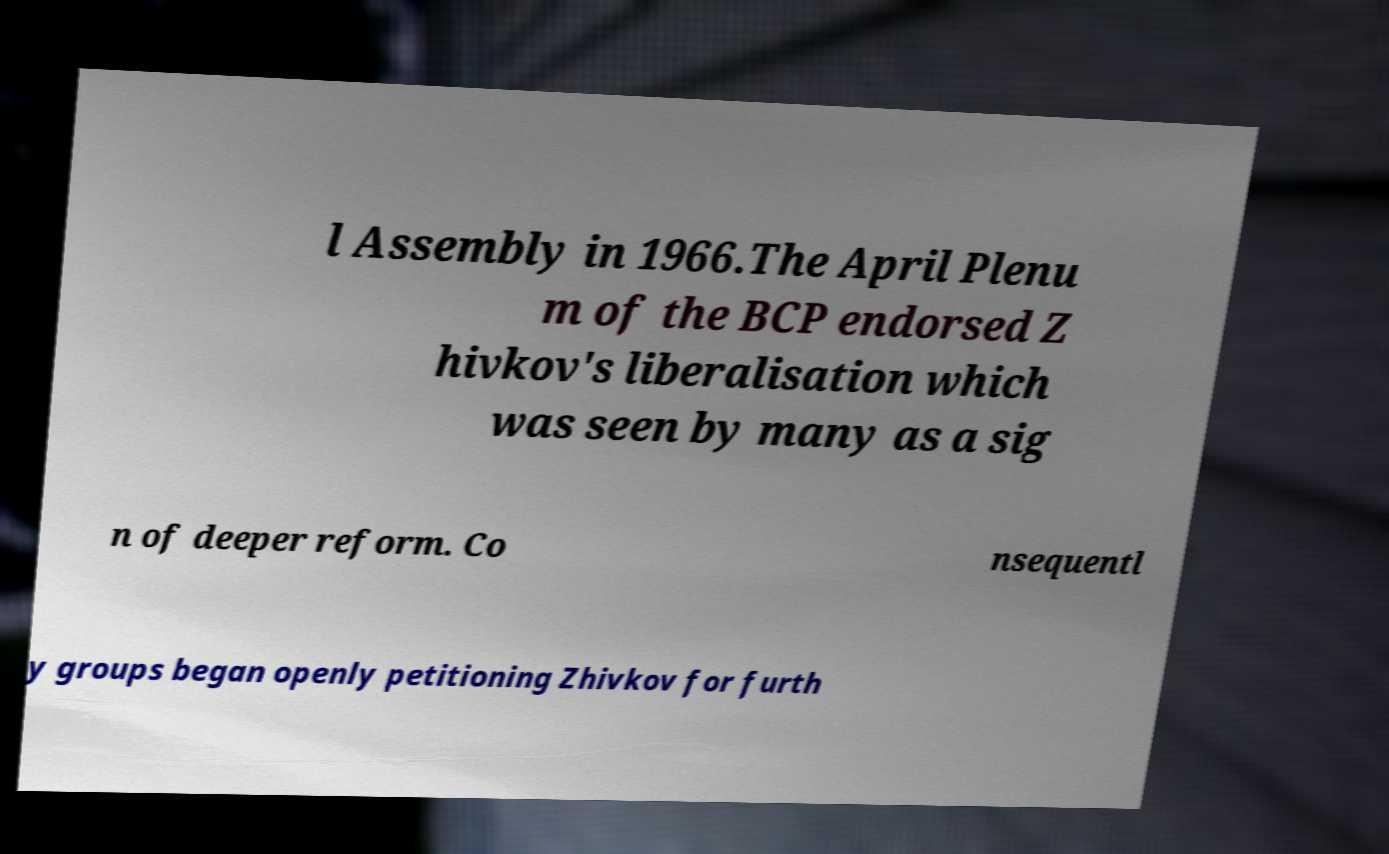Please identify and transcribe the text found in this image. l Assembly in 1966.The April Plenu m of the BCP endorsed Z hivkov's liberalisation which was seen by many as a sig n of deeper reform. Co nsequentl y groups began openly petitioning Zhivkov for furth 